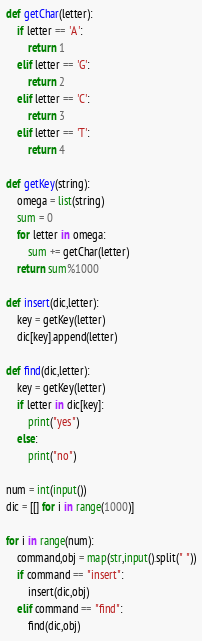<code> <loc_0><loc_0><loc_500><loc_500><_Python_>def getChar(letter):
    if letter == 'A':
        return 1
    elif letter == 'G':
        return 2
    elif letter == 'C':
        return 3
    elif letter == 'T':
        return 4

def getKey(string):
    omega = list(string)
    sum = 0
    for letter in omega:
        sum += getChar(letter)
    return sum%1000

def insert(dic,letter):
    key = getKey(letter)
    dic[key].append(letter)

def find(dic,letter):
    key = getKey(letter)
    if letter in dic[key]:
        print("yes")
    else:
        print("no")

num = int(input())
dic = [[] for i in range(1000)]

for i in range(num):
    command,obj = map(str,input().split(" "))
    if command == "insert":
        insert(dic,obj)
    elif command == "find":
        find(dic,obj)

</code> 